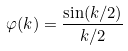<formula> <loc_0><loc_0><loc_500><loc_500>\varphi ( k ) = \frac { \sin ( k / 2 ) } { k / 2 }</formula> 